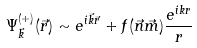<formula> <loc_0><loc_0><loc_500><loc_500>\Psi _ { \vec { k } } ^ { ( + ) } ( \vec { r } ) \sim e ^ { i \vec { k } \vec { r } } + f ( \vec { n } \vec { m } ) \frac { e ^ { i k r } } { r }</formula> 